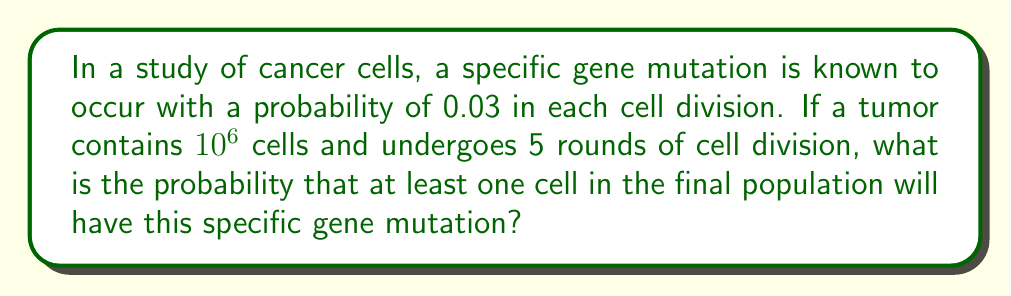Can you solve this math problem? Let's approach this problem step-by-step:

1) First, we need to calculate the total number of cells after 5 rounds of division:
   $10^6 \times 2^5 = 10^6 \times 32 = 32 \times 10^6$ cells

2) Now, let's consider the probability of a cell NOT having the mutation:
   $P(\text{no mutation}) = 1 - 0.03 = 0.97$

3) For the entire population to have no mutations, every cell must not have the mutation:
   $P(\text{no mutations in population}) = (0.97)^{32 \times 10^6}$

4) Therefore, the probability of at least one cell having the mutation is:
   $P(\text{at least one mutation}) = 1 - P(\text{no mutations in population})$
   $= 1 - (0.97)^{32 \times 10^6}$

5) To calculate this:
   $1 - (0.97)^{32 \times 10^6} = 1 - e^{(32 \times 10^6) \times \ln(0.97)}$
   $= 1 - e^{-0.97 \times 10^6}$
   $\approx 1 - 0$
   $\approx 1$

The probability is extremely close to 1, indicating that it's almost certain that at least one cell will have the mutation.
Answer: The probability is approximately 1 or 100%. 